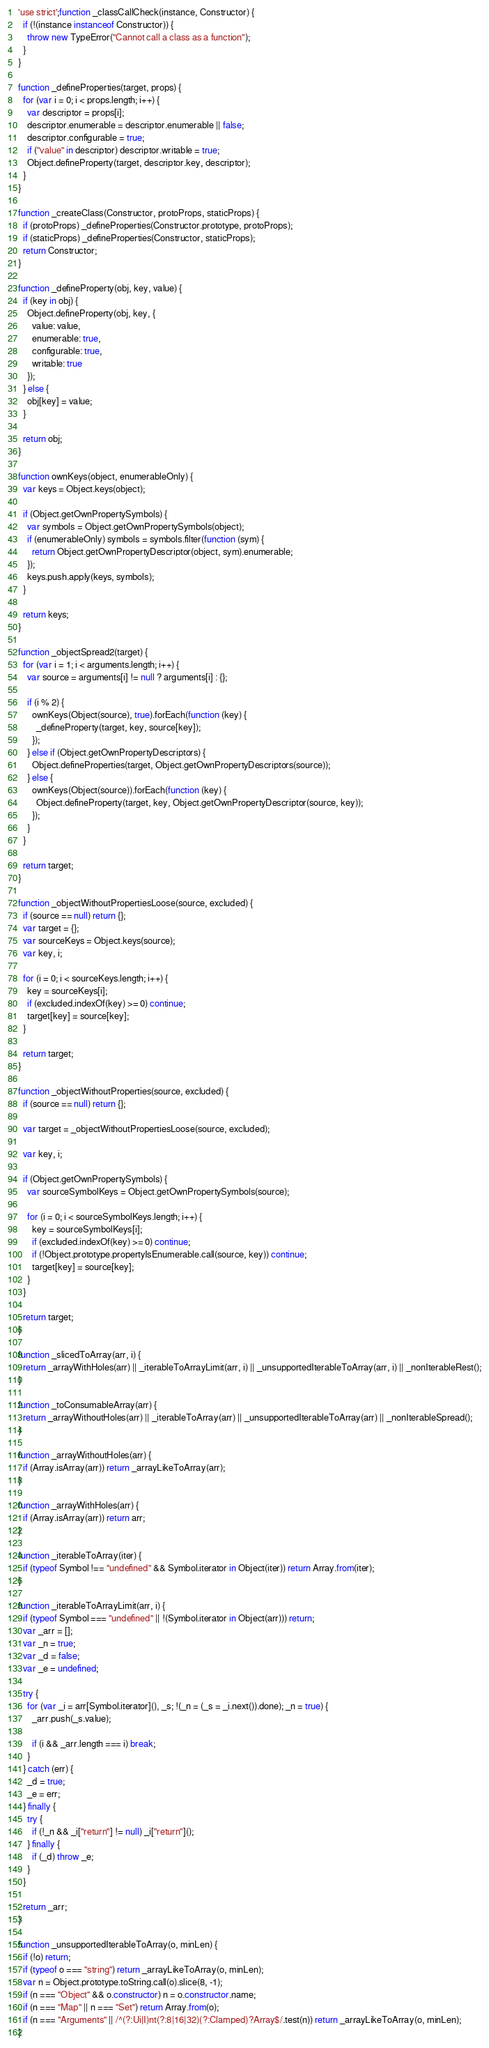<code> <loc_0><loc_0><loc_500><loc_500><_JavaScript_>'use strict';function _classCallCheck(instance, Constructor) {
  if (!(instance instanceof Constructor)) {
    throw new TypeError("Cannot call a class as a function");
  }
}

function _defineProperties(target, props) {
  for (var i = 0; i < props.length; i++) {
    var descriptor = props[i];
    descriptor.enumerable = descriptor.enumerable || false;
    descriptor.configurable = true;
    if ("value" in descriptor) descriptor.writable = true;
    Object.defineProperty(target, descriptor.key, descriptor);
  }
}

function _createClass(Constructor, protoProps, staticProps) {
  if (protoProps) _defineProperties(Constructor.prototype, protoProps);
  if (staticProps) _defineProperties(Constructor, staticProps);
  return Constructor;
}

function _defineProperty(obj, key, value) {
  if (key in obj) {
    Object.defineProperty(obj, key, {
      value: value,
      enumerable: true,
      configurable: true,
      writable: true
    });
  } else {
    obj[key] = value;
  }

  return obj;
}

function ownKeys(object, enumerableOnly) {
  var keys = Object.keys(object);

  if (Object.getOwnPropertySymbols) {
    var symbols = Object.getOwnPropertySymbols(object);
    if (enumerableOnly) symbols = symbols.filter(function (sym) {
      return Object.getOwnPropertyDescriptor(object, sym).enumerable;
    });
    keys.push.apply(keys, symbols);
  }

  return keys;
}

function _objectSpread2(target) {
  for (var i = 1; i < arguments.length; i++) {
    var source = arguments[i] != null ? arguments[i] : {};

    if (i % 2) {
      ownKeys(Object(source), true).forEach(function (key) {
        _defineProperty(target, key, source[key]);
      });
    } else if (Object.getOwnPropertyDescriptors) {
      Object.defineProperties(target, Object.getOwnPropertyDescriptors(source));
    } else {
      ownKeys(Object(source)).forEach(function (key) {
        Object.defineProperty(target, key, Object.getOwnPropertyDescriptor(source, key));
      });
    }
  }

  return target;
}

function _objectWithoutPropertiesLoose(source, excluded) {
  if (source == null) return {};
  var target = {};
  var sourceKeys = Object.keys(source);
  var key, i;

  for (i = 0; i < sourceKeys.length; i++) {
    key = sourceKeys[i];
    if (excluded.indexOf(key) >= 0) continue;
    target[key] = source[key];
  }

  return target;
}

function _objectWithoutProperties(source, excluded) {
  if (source == null) return {};

  var target = _objectWithoutPropertiesLoose(source, excluded);

  var key, i;

  if (Object.getOwnPropertySymbols) {
    var sourceSymbolKeys = Object.getOwnPropertySymbols(source);

    for (i = 0; i < sourceSymbolKeys.length; i++) {
      key = sourceSymbolKeys[i];
      if (excluded.indexOf(key) >= 0) continue;
      if (!Object.prototype.propertyIsEnumerable.call(source, key)) continue;
      target[key] = source[key];
    }
  }

  return target;
}

function _slicedToArray(arr, i) {
  return _arrayWithHoles(arr) || _iterableToArrayLimit(arr, i) || _unsupportedIterableToArray(arr, i) || _nonIterableRest();
}

function _toConsumableArray(arr) {
  return _arrayWithoutHoles(arr) || _iterableToArray(arr) || _unsupportedIterableToArray(arr) || _nonIterableSpread();
}

function _arrayWithoutHoles(arr) {
  if (Array.isArray(arr)) return _arrayLikeToArray(arr);
}

function _arrayWithHoles(arr) {
  if (Array.isArray(arr)) return arr;
}

function _iterableToArray(iter) {
  if (typeof Symbol !== "undefined" && Symbol.iterator in Object(iter)) return Array.from(iter);
}

function _iterableToArrayLimit(arr, i) {
  if (typeof Symbol === "undefined" || !(Symbol.iterator in Object(arr))) return;
  var _arr = [];
  var _n = true;
  var _d = false;
  var _e = undefined;

  try {
    for (var _i = arr[Symbol.iterator](), _s; !(_n = (_s = _i.next()).done); _n = true) {
      _arr.push(_s.value);

      if (i && _arr.length === i) break;
    }
  } catch (err) {
    _d = true;
    _e = err;
  } finally {
    try {
      if (!_n && _i["return"] != null) _i["return"]();
    } finally {
      if (_d) throw _e;
    }
  }

  return _arr;
}

function _unsupportedIterableToArray(o, minLen) {
  if (!o) return;
  if (typeof o === "string") return _arrayLikeToArray(o, minLen);
  var n = Object.prototype.toString.call(o).slice(8, -1);
  if (n === "Object" && o.constructor) n = o.constructor.name;
  if (n === "Map" || n === "Set") return Array.from(o);
  if (n === "Arguments" || /^(?:Ui|I)nt(?:8|16|32)(?:Clamped)?Array$/.test(n)) return _arrayLikeToArray(o, minLen);
}
</code> 